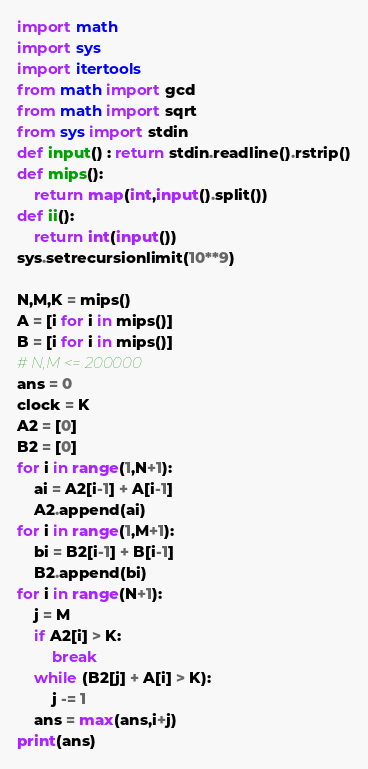Convert code to text. <code><loc_0><loc_0><loc_500><loc_500><_Python_>import math
import sys
import itertools
from math import gcd
from math import sqrt
from sys import stdin
def input() : return stdin.readline().rstrip()
def mips():
    return map(int,input().split())
def ii():
    return int(input())
sys.setrecursionlimit(10**9)

N,M,K = mips()
A = [i for i in mips()]
B = [i for i in mips()]
# N,M <= 200000
ans = 0
clock = K
A2 = [0]
B2 = [0]
for i in range(1,N+1):
    ai = A2[i-1] + A[i-1]
    A2.append(ai)
for i in range(1,M+1):
    bi = B2[i-1] + B[i-1]
    B2.append(bi)
for i in range(N+1):
    j = M
    if A2[i] > K:
        break
    while (B2[j] + A[i] > K):
        j -= 1
    ans = max(ans,i+j)
print(ans)</code> 